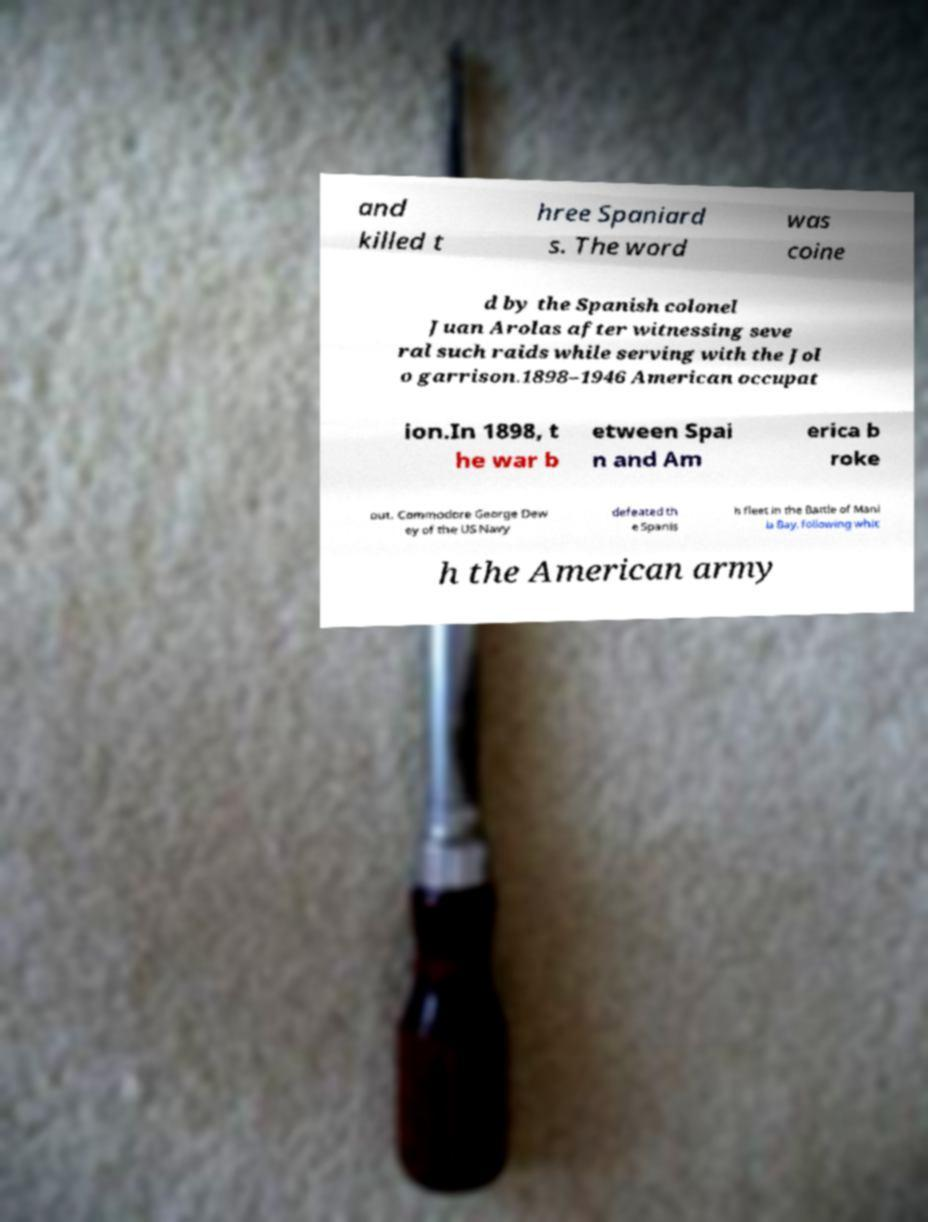Please read and relay the text visible in this image. What does it say? and killed t hree Spaniard s. The word was coine d by the Spanish colonel Juan Arolas after witnessing seve ral such raids while serving with the Jol o garrison.1898–1946 American occupat ion.In 1898, t he war b etween Spai n and Am erica b roke out. Commodore George Dew ey of the US Navy defeated th e Spanis h fleet in the Battle of Mani la Bay, following whic h the American army 